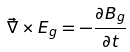<formula> <loc_0><loc_0><loc_500><loc_500>\vec { \nabla } \times E _ { g } = - \frac { \partial B _ { g } } { \partial t }</formula> 